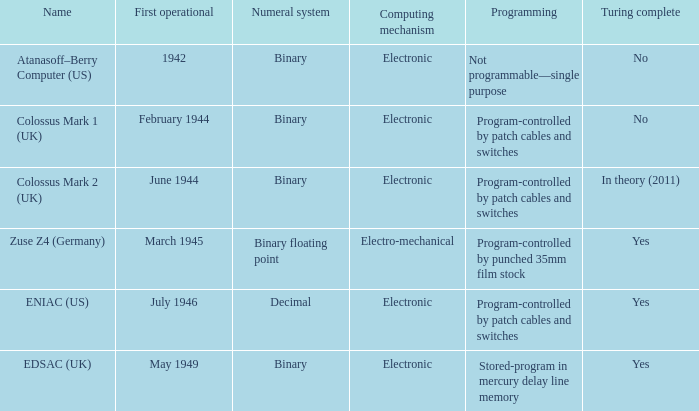What's the turing complete with numeral system being decimal Yes. Help me parse the entirety of this table. {'header': ['Name', 'First operational', 'Numeral system', 'Computing mechanism', 'Programming', 'Turing complete'], 'rows': [['Atanasoff–Berry Computer (US)', '1942', 'Binary', 'Electronic', 'Not programmable—single purpose', 'No'], ['Colossus Mark 1 (UK)', 'February 1944', 'Binary', 'Electronic', 'Program-controlled by patch cables and switches', 'No'], ['Colossus Mark 2 (UK)', 'June 1944', 'Binary', 'Electronic', 'Program-controlled by patch cables and switches', 'In theory (2011)'], ['Zuse Z4 (Germany)', 'March 1945', 'Binary floating point', 'Electro-mechanical', 'Program-controlled by punched 35mm film stock', 'Yes'], ['ENIAC (US)', 'July 1946', 'Decimal', 'Electronic', 'Program-controlled by patch cables and switches', 'Yes'], ['EDSAC (UK)', 'May 1949', 'Binary', 'Electronic', 'Stored-program in mercury delay line memory', 'Yes']]} 